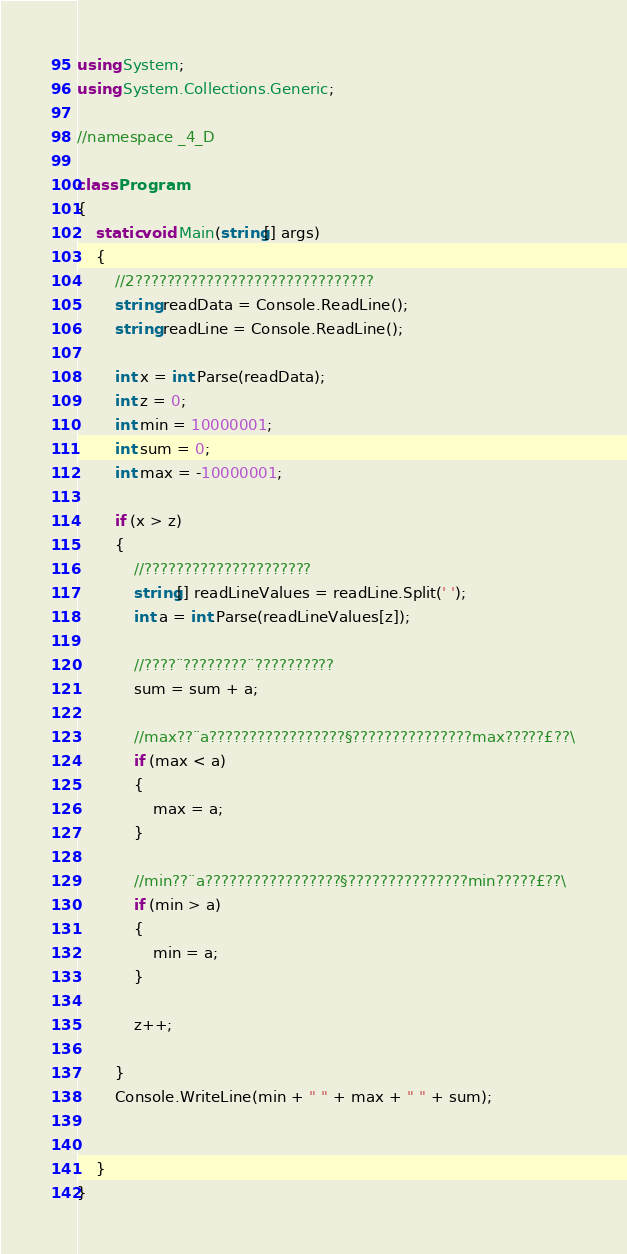<code> <loc_0><loc_0><loc_500><loc_500><_C#_>using System;
using System.Collections.Generic;

//namespace _4_D

class Program
{
    static void Main(string[] args)
    {
        //2??????????????????????????????
        string readData = Console.ReadLine();
        string readLine = Console.ReadLine();

        int x = int.Parse(readData);
        int z = 0;
        int min = 10000001;
        int sum = 0;
        int max = -10000001;

        if (x > z)
        {
            //?????????????????????
            string[] readLineValues = readLine.Split(' ');
            int a = int.Parse(readLineValues[z]);

            //????¨????????¨??????????
            sum = sum + a;

            //max??¨a?????????????????§???????????????max?????£??\
            if (max < a)
            {
                max = a;
            }

            //min??¨a?????????????????§???????????????min?????£??\
            if (min > a)
            {
                min = a;
            }

            z++;

        }
        Console.WriteLine(min + " " + max + " " + sum);


    }
}</code> 